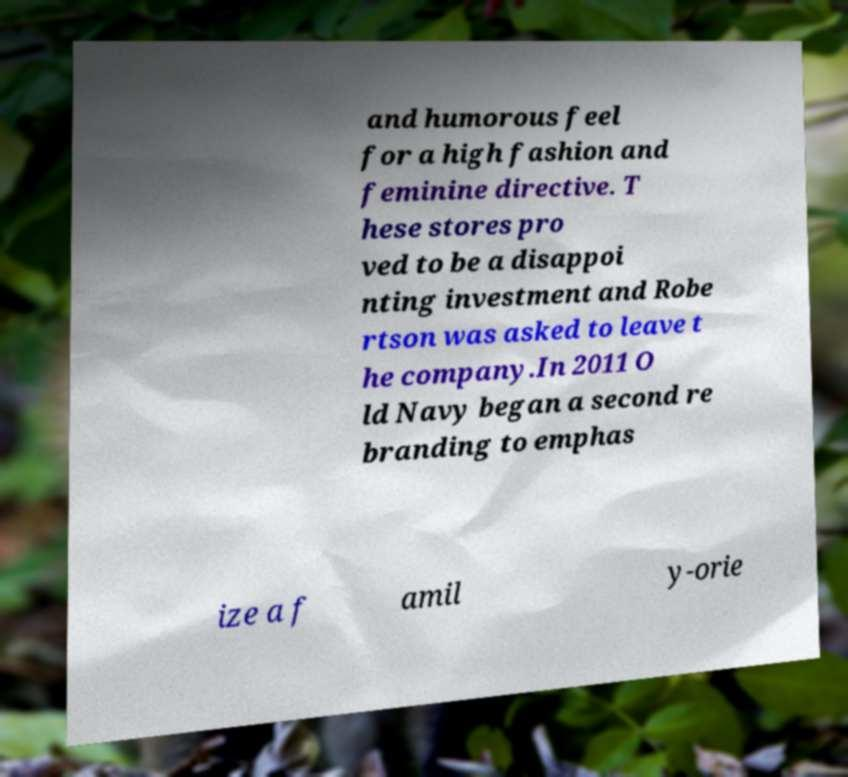Could you extract and type out the text from this image? and humorous feel for a high fashion and feminine directive. T hese stores pro ved to be a disappoi nting investment and Robe rtson was asked to leave t he company.In 2011 O ld Navy began a second re branding to emphas ize a f amil y-orie 